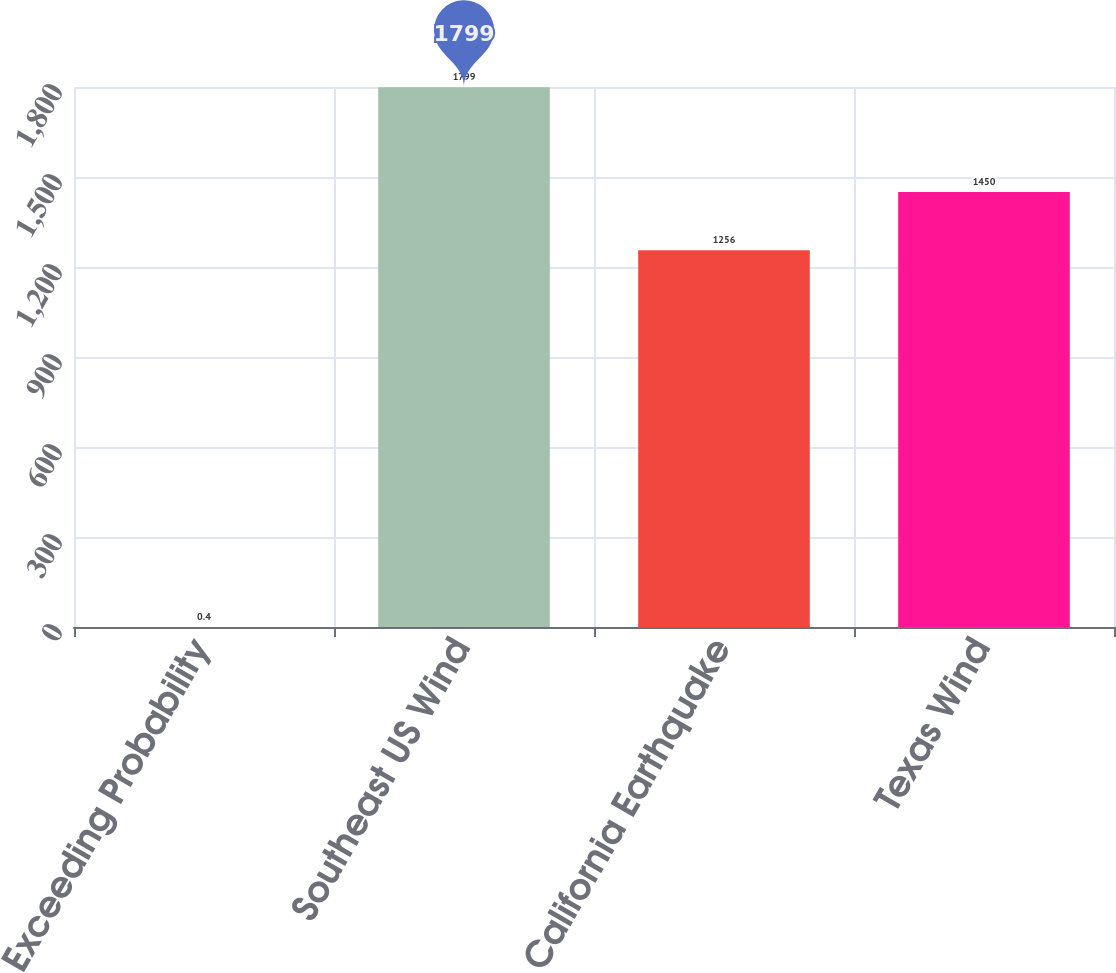Convert chart. <chart><loc_0><loc_0><loc_500><loc_500><bar_chart><fcel>Exceeding Probability<fcel>Southeast US Wind<fcel>California Earthquake<fcel>Texas Wind<nl><fcel>0.4<fcel>1799<fcel>1256<fcel>1450<nl></chart> 